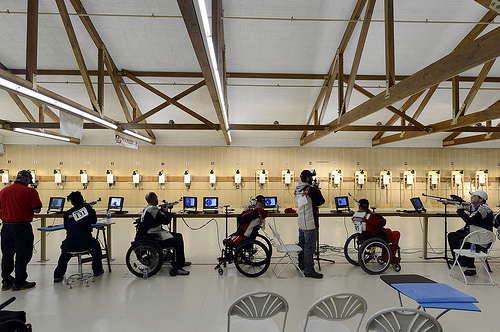<image>
Can you confirm if the target is behind the shooter? No. The target is not behind the shooter. From this viewpoint, the target appears to be positioned elsewhere in the scene. Is there a man to the left of the man? No. The man is not to the left of the man. From this viewpoint, they have a different horizontal relationship. 